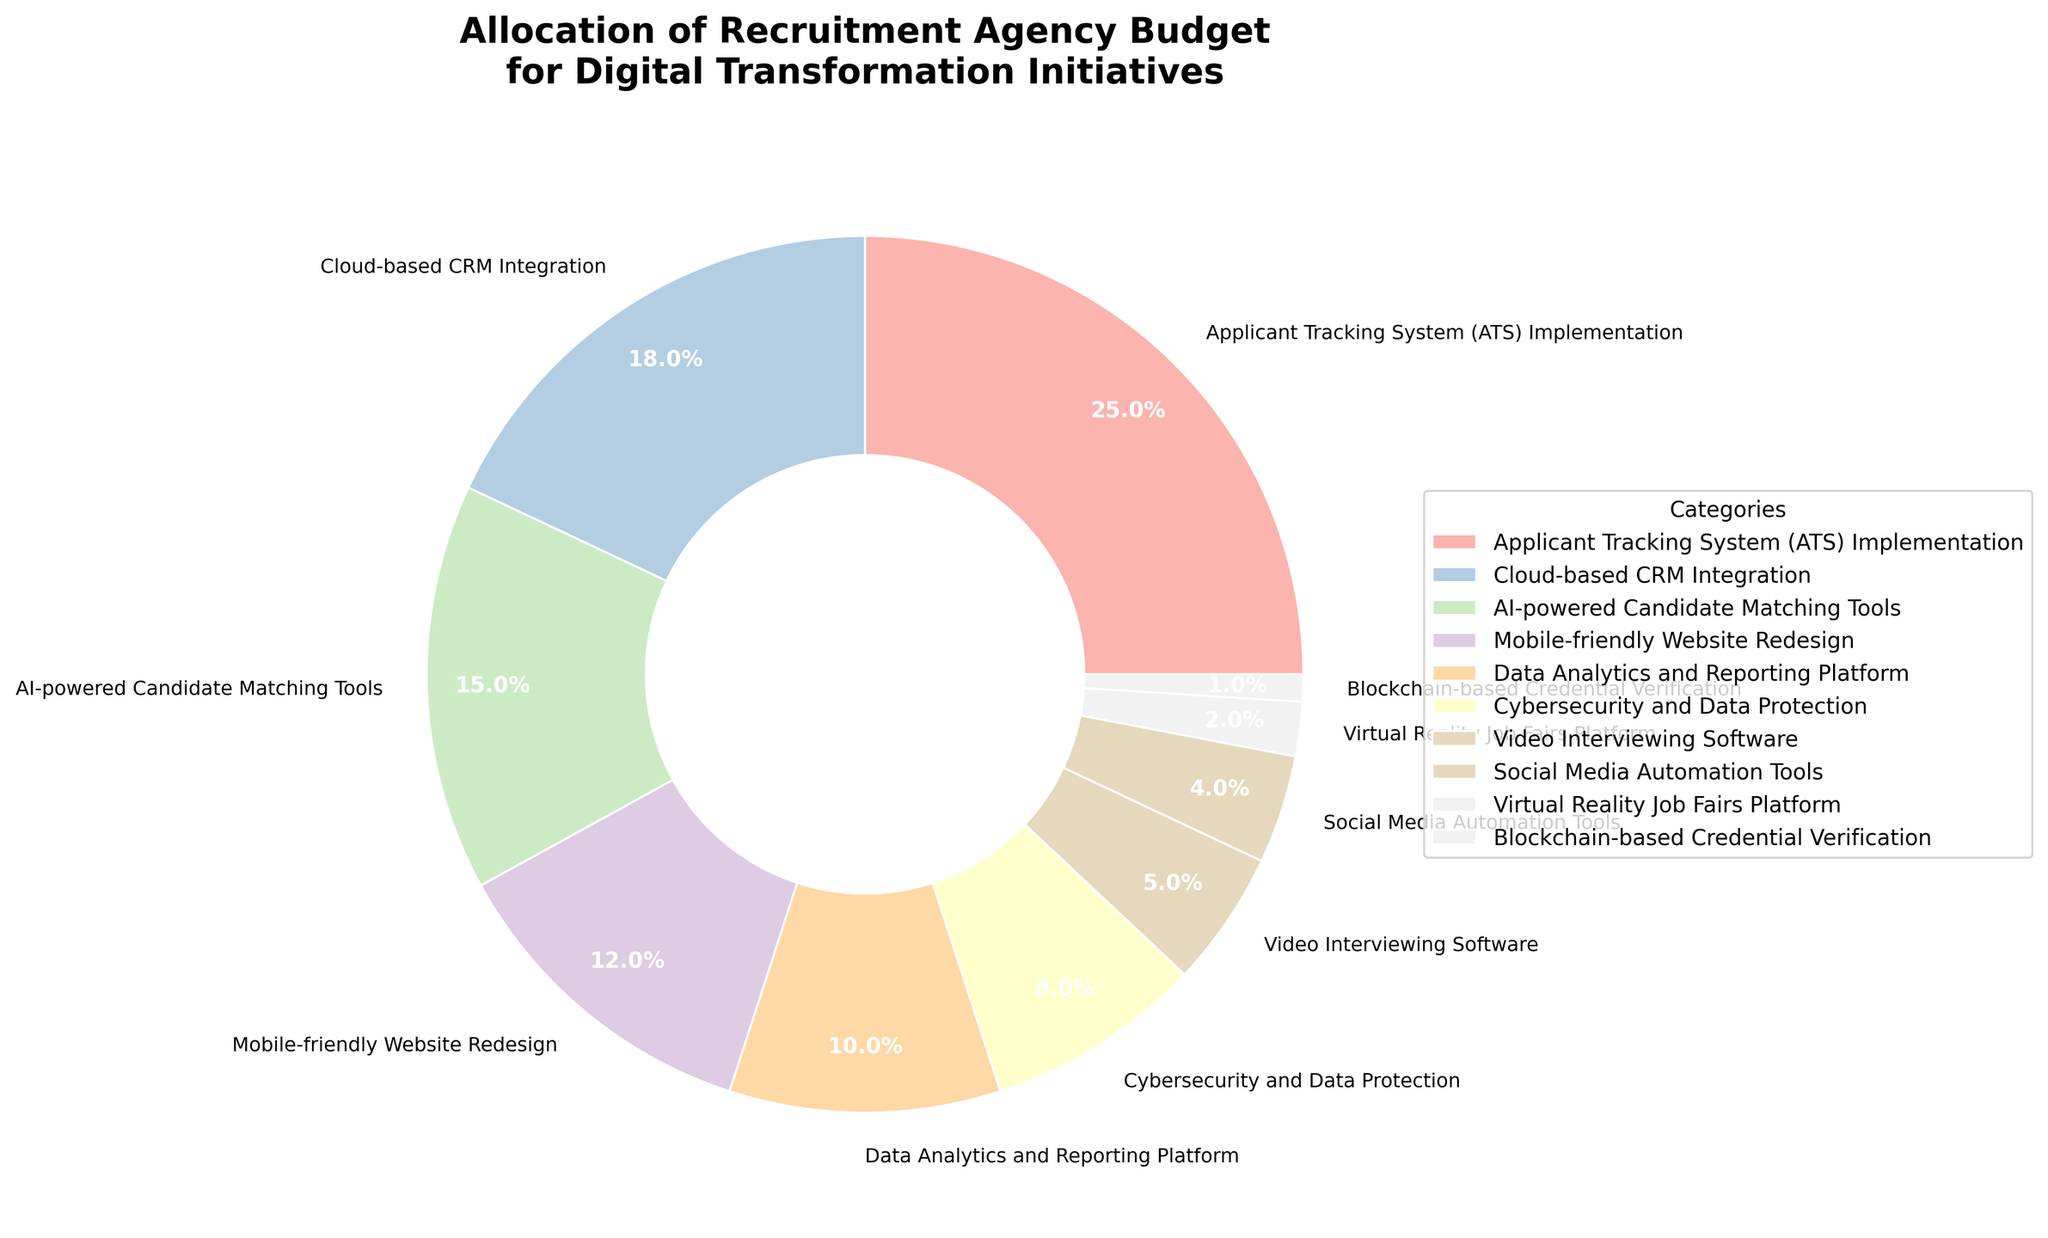What category receives the highest budget allocation? The category with the largest percentage in the pie chart is the one receiving the highest budget allocation. From the chart, Applicant Tracking System (ATS) Implementation has the highest percentage.
Answer: Applicant Tracking System (ATS) Implementation Which two categories have the lowest budget allocations, and what are their combined percentages? The categories with the smallest percentages on the chart are Virtual Reality Job Fairs Platform and Blockchain-based Credential Verification. Summing their percentages gives 2 + 1.
Answer: Virtual Reality Job Fairs Platform and Blockchain-based Credential Verification, 3% How much higher is the budget for Cybersecurity and Data Protection compared to Video Interviewing Software? The percentages for Cybersecurity and Data Protection and Video Interviewing Software are 8% and 5%, respectively. The difference is calculated as 8 - 5.
Answer: 3% Which category has a budget allocation closest to 20%? From the pie chart, the category that has a budget percentage closest to 20% is Cloud-based CRM Integration at 18%.
Answer: Cloud-based CRM Integration What is the total budget allocation for AI-powered Candidate Matching Tools, Mobile-friendly Website Redesign, and Data Analytics and Reporting Platform? The percentages for AI-powered Candidate Matching Tools, Mobile-friendly Website Redesign, and Data Analytics and Reporting Platform are 15%, 12%, and 10%. Summing these gives 15 + 12 + 10.
Answer: 37% How does the budget allocation for Social Media Automation Tools compare to that for Mobile-friendly Website Redesign? The pie chart shows percentages of 4% for Social Media Automation Tools and 12% for Mobile-friendly Website Redesign. Comparing these values, 4% is less than 12%.
Answer: Social Media Automation Tools has a smaller budget allocation than Mobile-friendly Website Redesign How much larger is the combined allocation for ATS Implementation and Cloud-based CRM Integration compared to the combined allocation for Video Interviewing Software and Social Media Automation Tools? The combined allocation for ATS Implementation and Cloud-based CRM Integration is 25% + 18% = 43%. The combined allocation for Video Interviewing Software and Social Media Automation Tools is 5% + 4% = 9%. The difference is calculated as 43 - 9.
Answer: 34% What percentage of the budget is allocated to both Data Analytics and Reporting Platform and Cybersecurity and Data Protection? The percentages for Data Analytics and Reporting Platform and Cybersecurity and Data Protection are 10% and 8%, respectively. Summing these gives 10 + 8.
Answer: 18% Which three categories together form about 50% of the budget allocation? The three categories with the highest individual percentages are ATS Implementation (25%), Cloud-based CRM Integration (18%), and AI-powered Candidate Matching Tools (15%). Summing these gives 25 + 18 + 15 = 58%, which is closest to 50%.
Answer: ATS Implementation, Cloud-based CRM Integration, AI-powered Candidate Matching Tools In terms of color, which category is represented by the sixth color from the top in the legend? By counting the color positions in the legend, the sixth color corresponds to Cybersecurity and Data Protection, based on the list order.
Answer: Cybersecurity and Data Protection 